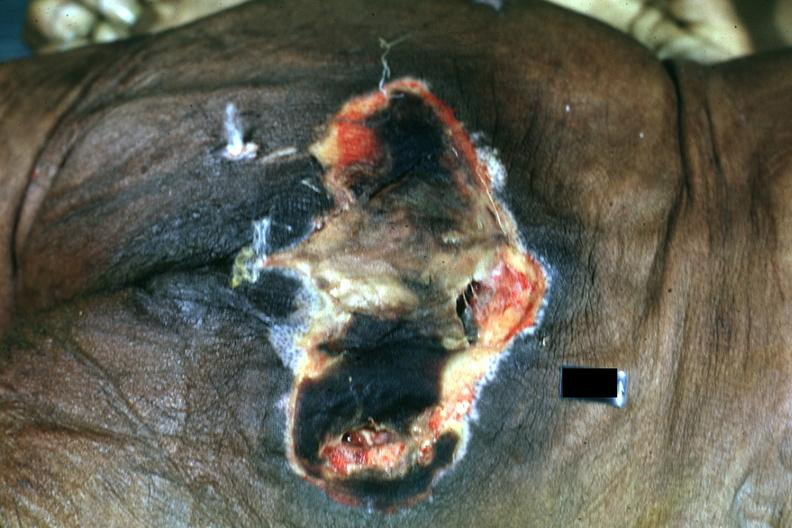s decubitus ulcer present?
Answer the question using a single word or phrase. Yes 